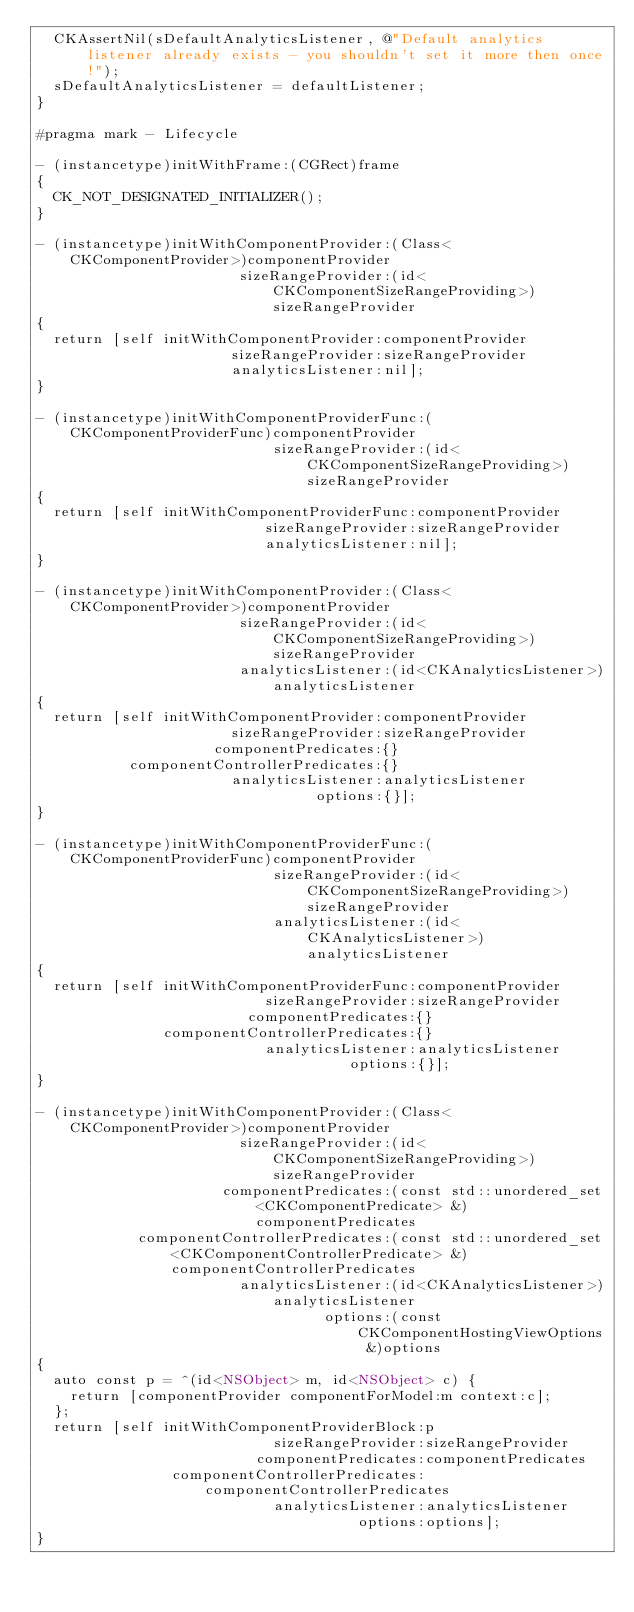Convert code to text. <code><loc_0><loc_0><loc_500><loc_500><_ObjectiveC_>  CKAssertNil(sDefaultAnalyticsListener, @"Default analytics listener already exists - you shouldn't set it more then once!");
  sDefaultAnalyticsListener = defaultListener;
}

#pragma mark - Lifecycle

- (instancetype)initWithFrame:(CGRect)frame
{
  CK_NOT_DESIGNATED_INITIALIZER();
}

- (instancetype)initWithComponentProvider:(Class<CKComponentProvider>)componentProvider
                        sizeRangeProvider:(id<CKComponentSizeRangeProviding>)sizeRangeProvider
{
  return [self initWithComponentProvider:componentProvider
                       sizeRangeProvider:sizeRangeProvider
                       analyticsListener:nil];
}

- (instancetype)initWithComponentProviderFunc:(CKComponentProviderFunc)componentProvider
                            sizeRangeProvider:(id<CKComponentSizeRangeProviding>)sizeRangeProvider
{
  return [self initWithComponentProviderFunc:componentProvider
                           sizeRangeProvider:sizeRangeProvider
                           analyticsListener:nil];
}

- (instancetype)initWithComponentProvider:(Class<CKComponentProvider>)componentProvider
                        sizeRangeProvider:(id<CKComponentSizeRangeProviding>)sizeRangeProvider
                        analyticsListener:(id<CKAnalyticsListener>)analyticsListener
{
  return [self initWithComponentProvider:componentProvider
                       sizeRangeProvider:sizeRangeProvider
                     componentPredicates:{}
           componentControllerPredicates:{}
                       analyticsListener:analyticsListener
                                 options:{}];
}

- (instancetype)initWithComponentProviderFunc:(CKComponentProviderFunc)componentProvider
                            sizeRangeProvider:(id<CKComponentSizeRangeProviding>)sizeRangeProvider
                            analyticsListener:(id<CKAnalyticsListener>)analyticsListener
{
  return [self initWithComponentProviderFunc:componentProvider
                           sizeRangeProvider:sizeRangeProvider
                         componentPredicates:{}
               componentControllerPredicates:{}
                           analyticsListener:analyticsListener
                                     options:{}];
}

- (instancetype)initWithComponentProvider:(Class<CKComponentProvider>)componentProvider
                        sizeRangeProvider:(id<CKComponentSizeRangeProviding>)sizeRangeProvider
                      componentPredicates:(const std::unordered_set<CKComponentPredicate> &)componentPredicates
            componentControllerPredicates:(const std::unordered_set<CKComponentControllerPredicate> &)componentControllerPredicates
                        analyticsListener:(id<CKAnalyticsListener>)analyticsListener
                                  options:(const CKComponentHostingViewOptions &)options
{
  auto const p = ^(id<NSObject> m, id<NSObject> c) {
    return [componentProvider componentForModel:m context:c];
  };
  return [self initWithComponentProviderBlock:p
                            sizeRangeProvider:sizeRangeProvider
                          componentPredicates:componentPredicates
                componentControllerPredicates:componentControllerPredicates
                            analyticsListener:analyticsListener
                                      options:options];
}
</code> 